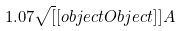Convert formula to latex. <formula><loc_0><loc_0><loc_500><loc_500>1 . 0 7 { \sqrt { [ } [ o b j e c t O b j e c t ] ] { A } }</formula> 